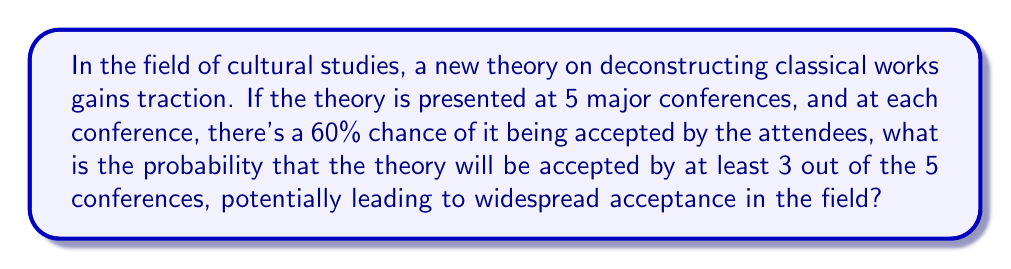Could you help me with this problem? To solve this problem, we need to use the binomial probability distribution, as we have a fixed number of independent trials (conferences) with two possible outcomes (acceptance or rejection) and a constant probability of success.

Let's break it down step-by-step:

1) We have n = 5 conferences (trials)
2) The probability of success (acceptance) at each conference is p = 0.60
3) We want the probability of at least 3 successes out of 5 trials

The binomial probability formula is:

$$ P(X = k) = \binom{n}{k} p^k (1-p)^{n-k} $$

Where:
- n is the number of trials
- k is the number of successes
- p is the probability of success on each trial

We need to calculate P(X ≥ 3), which is equivalent to P(X = 3) + P(X = 4) + P(X = 5)

Let's calculate each:

For k = 3:
$$ P(X = 3) = \binom{5}{3} (0.60)^3 (0.40)^2 = 10 \cdot 0.216 \cdot 0.16 = 0.3456 $$

For k = 4:
$$ P(X = 4) = \binom{5}{4} (0.60)^4 (0.40)^1 = 5 \cdot 0.1296 \cdot 0.40 = 0.2592 $$

For k = 5:
$$ P(X = 5) = \binom{5}{5} (0.60)^5 (0.40)^0 = 1 \cdot 0.07776 \cdot 1 = 0.07776 $$

Now, we sum these probabilities:

$$ P(X \geq 3) = 0.3456 + 0.2592 + 0.07776 = 0.68256 $$

Therefore, the probability of the theory being accepted by at least 3 out of 5 conferences is approximately 0.6826 or 68.26%.
Answer: 0.6826 